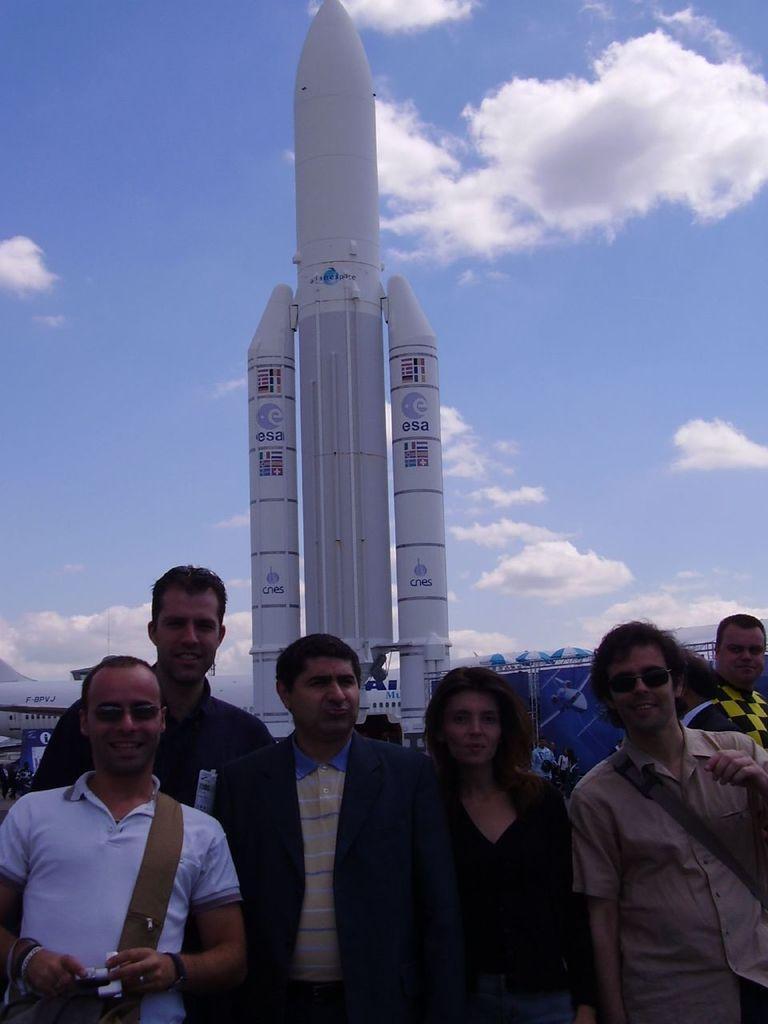Please provide a concise description of this image. In this image we can see these people are standing here. In the background, we can see an airplane, rocket, banners and the blue color sky with clouds. 